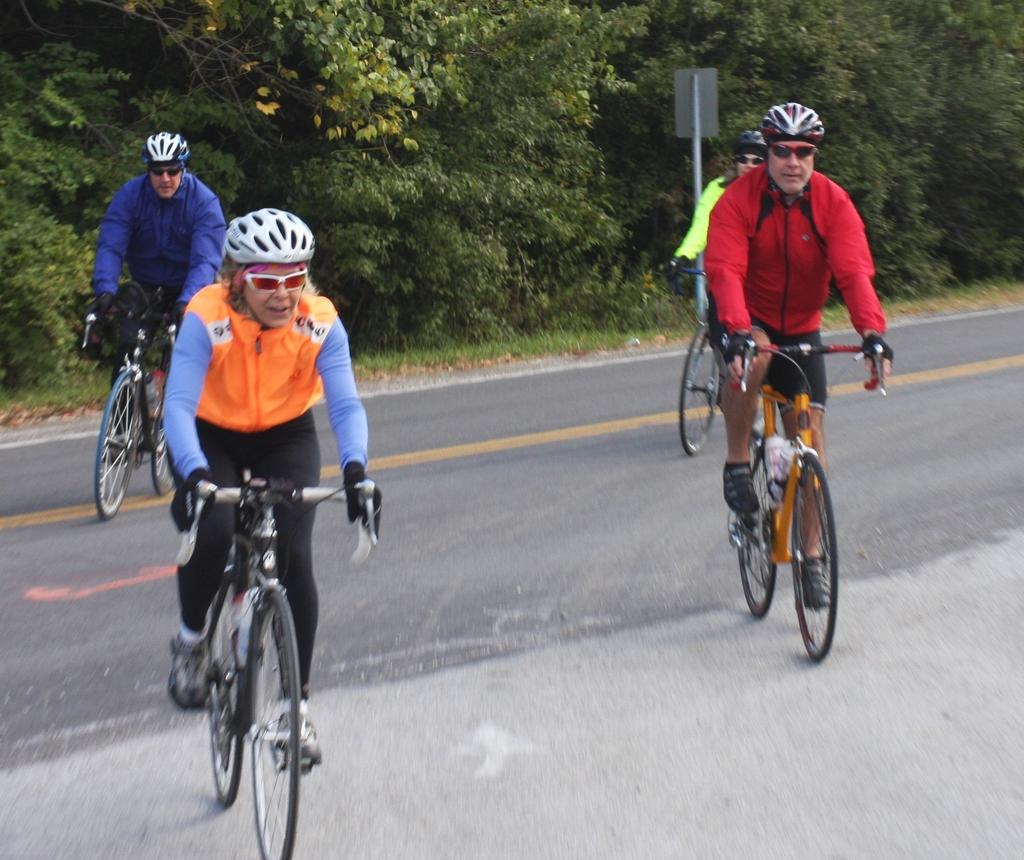How many people are in the image? There are four people in the image. What are the people doing in the image? The people are riding bicycles. What accessories are the people wearing in the image? The people are wearing spectacles and helmets. Where is the image set? The image is set on a road. What is the feeling of the road in the image? The image does not convey a feeling of the road; it only shows the people riding bicycles on it. How does the acoustics of the image contribute to the overall experience? The image does not have any auditory elements, so there are no acoustics to consider. 